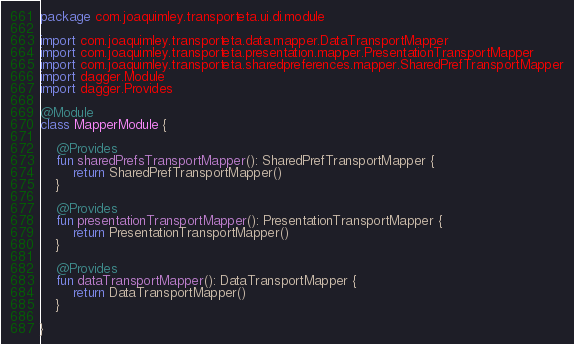<code> <loc_0><loc_0><loc_500><loc_500><_Kotlin_>package com.joaquimley.transporteta.ui.di.module

import com.joaquimley.transporteta.data.mapper.DataTransportMapper
import com.joaquimley.transporteta.presentation.mapper.PresentationTransportMapper
import com.joaquimley.transporteta.sharedpreferences.mapper.SharedPrefTransportMapper
import dagger.Module
import dagger.Provides

@Module
class MapperModule {

    @Provides
    fun sharedPrefsTransportMapper(): SharedPrefTransportMapper {
        return SharedPrefTransportMapper()
    }

    @Provides
    fun presentationTransportMapper(): PresentationTransportMapper {
        return PresentationTransportMapper()
    }

    @Provides
    fun dataTransportMapper(): DataTransportMapper {
        return DataTransportMapper()
    }

}
</code> 